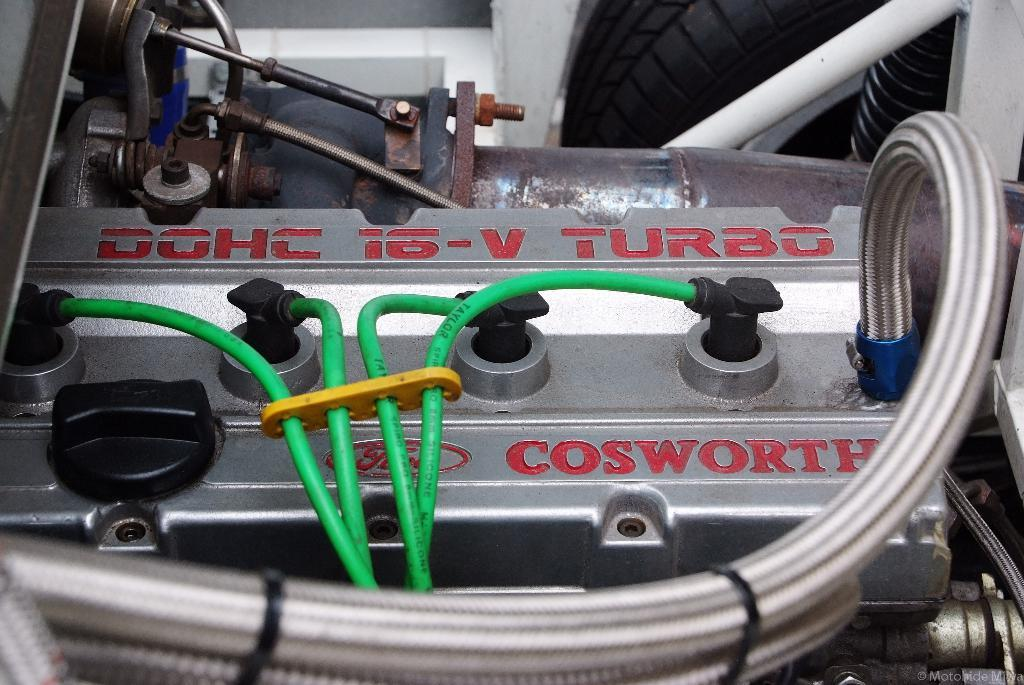What is the main object in the middle of the image? There is a motor in the middle of the image. Are there any connections to the motor? Yes, wires are connected to the motor. What can be seen in the right side top corner of the image? There is a tire in the right side top corner of the image. Where is the grandmother sitting with her vase in the image? There is no grandmother or vase present in the image. 